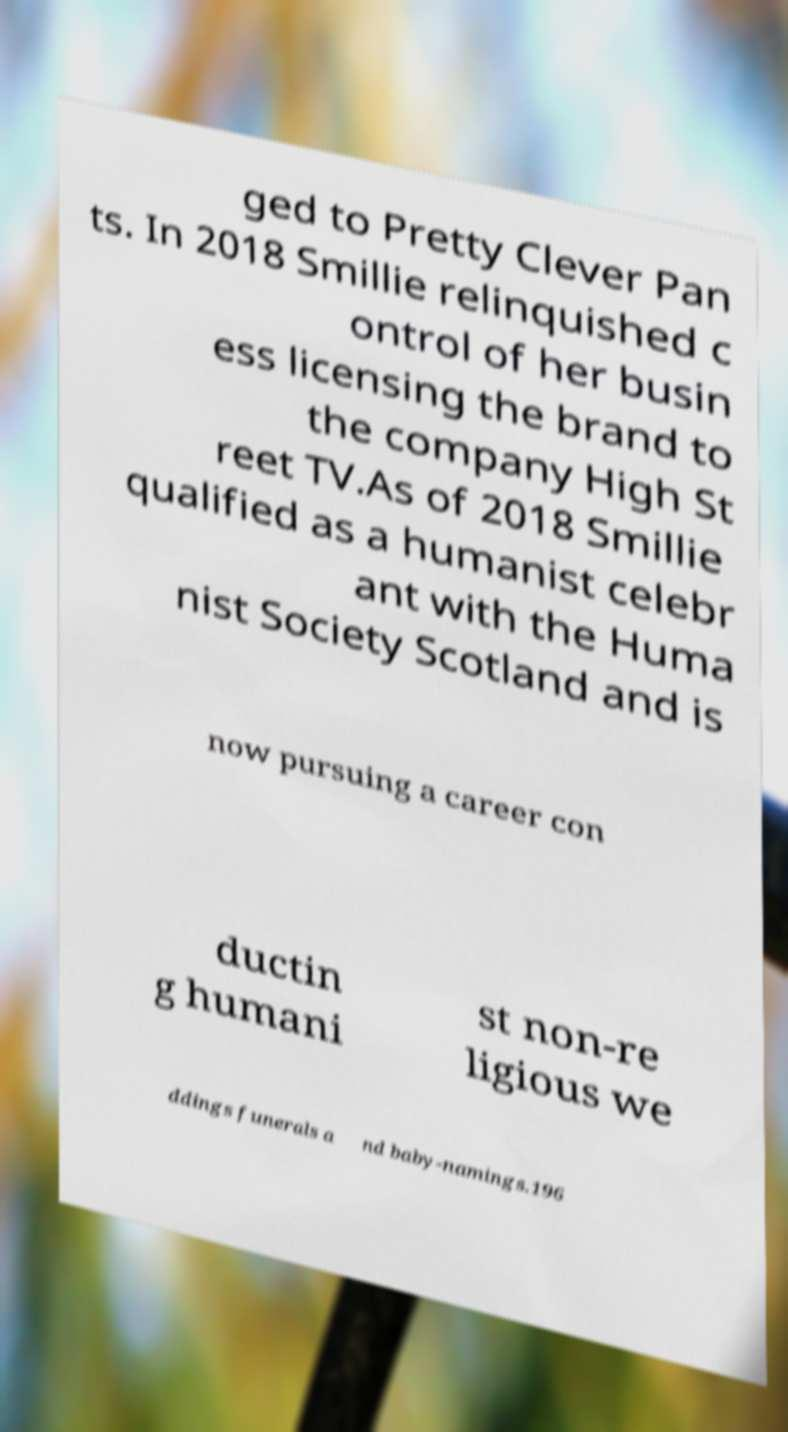Please read and relay the text visible in this image. What does it say? ged to Pretty Clever Pan ts. In 2018 Smillie relinquished c ontrol of her busin ess licensing the brand to the company High St reet TV.As of 2018 Smillie qualified as a humanist celebr ant with the Huma nist Society Scotland and is now pursuing a career con ductin g humani st non-re ligious we ddings funerals a nd baby-namings.196 